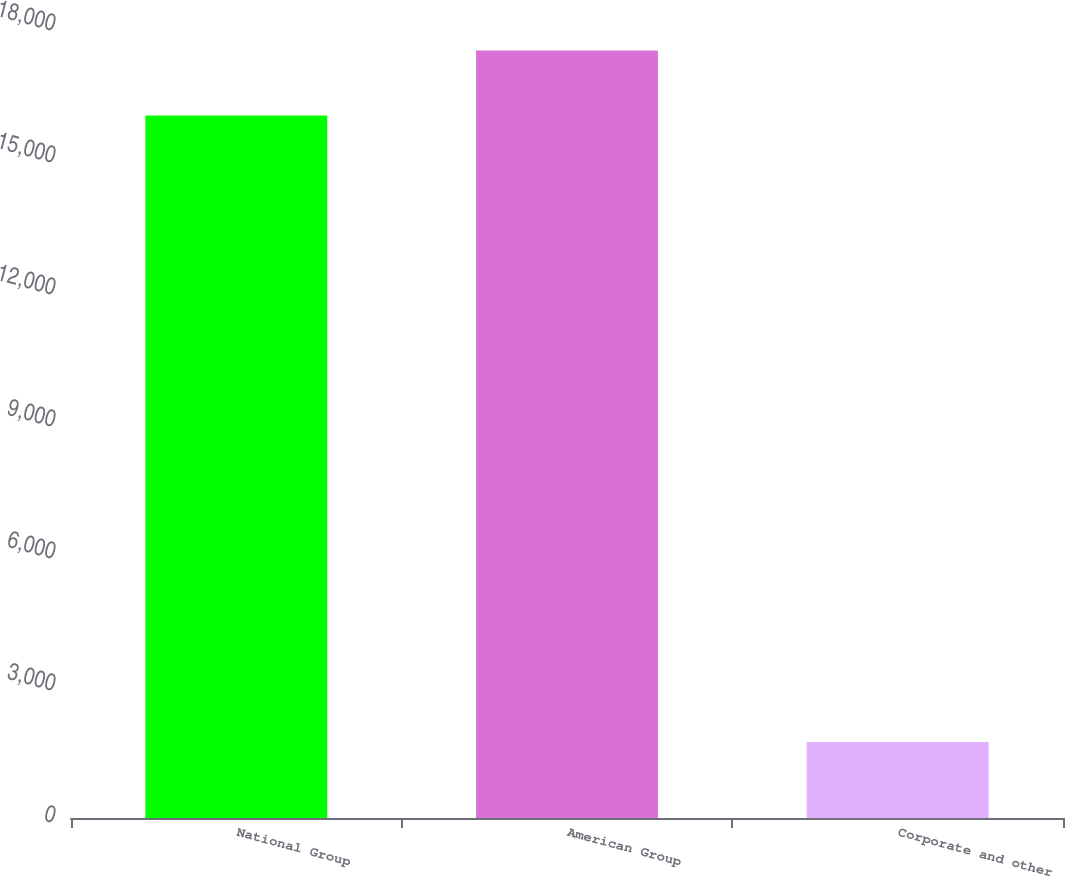Convert chart. <chart><loc_0><loc_0><loc_500><loc_500><bar_chart><fcel>National Group<fcel>American Group<fcel>Corporate and other<nl><fcel>15968<fcel>17444<fcel>1727<nl></chart> 